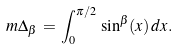<formula> <loc_0><loc_0><loc_500><loc_500>\ m { \Delta _ { \beta } \, = \, \int ^ { \pi / 2 } _ { 0 } \, \sin ^ { \beta } ( x ) \, d x } .</formula> 